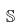<formula> <loc_0><loc_0><loc_500><loc_500>\mathbb { S }</formula> 